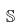<formula> <loc_0><loc_0><loc_500><loc_500>\mathbb { S }</formula> 